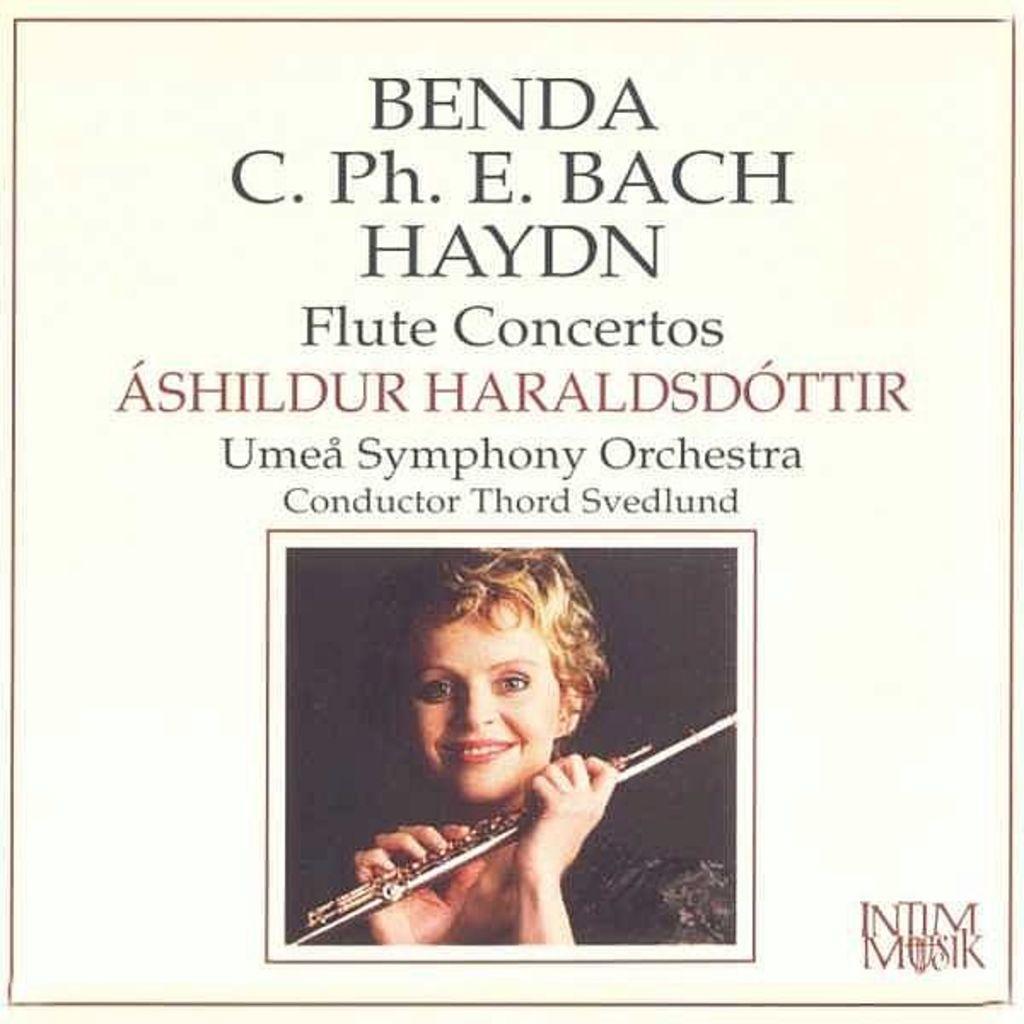Please provide a concise description of this image. This is a poster, in this image at the top of there is some text, in the center there is one person who is holding some stick. 